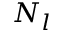Convert formula to latex. <formula><loc_0><loc_0><loc_500><loc_500>N _ { l }</formula> 